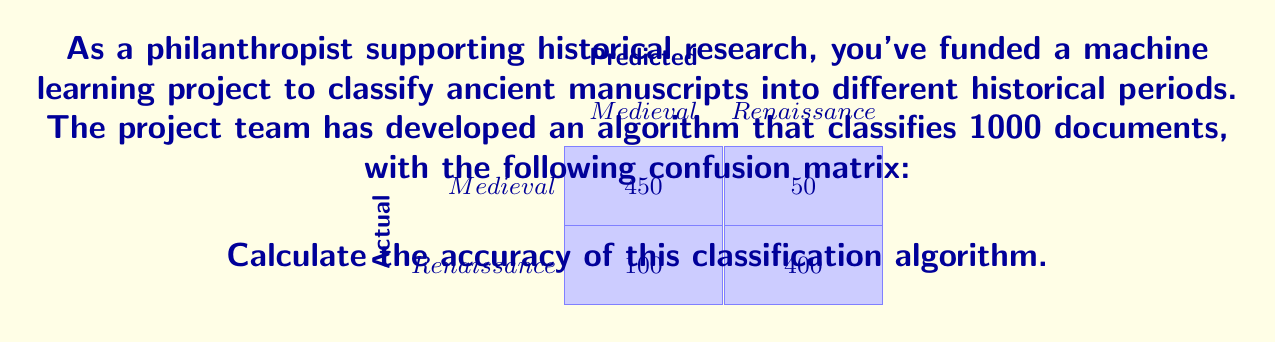Solve this math problem. To calculate the accuracy of the classification algorithm, we need to determine the proportion of correct predictions out of the total number of predictions. Let's break it down step-by-step:

1. Identify the total number of documents:
   Total documents = 450 + 50 + 100 + 400 = 1000

2. Identify the number of correct predictions:
   Correct predictions = True Positives + True Negatives
   - True Positives (Medieval correctly classified as Medieval) = 450
   - True Negatives (Renaissance correctly classified as Renaissance) = 400
   Correct predictions = 450 + 400 = 850

3. Calculate the accuracy using the formula:
   $$ \text{Accuracy} = \frac{\text{Number of Correct Predictions}}{\text{Total Number of Predictions}} $$

4. Plug in the values:
   $$ \text{Accuracy} = \frac{850}{1000} = 0.85 $$

5. Convert to percentage:
   $$ \text{Accuracy} = 0.85 \times 100\% = 85\% $$

Therefore, the accuracy of the classification algorithm is 85%.
Answer: 85% 